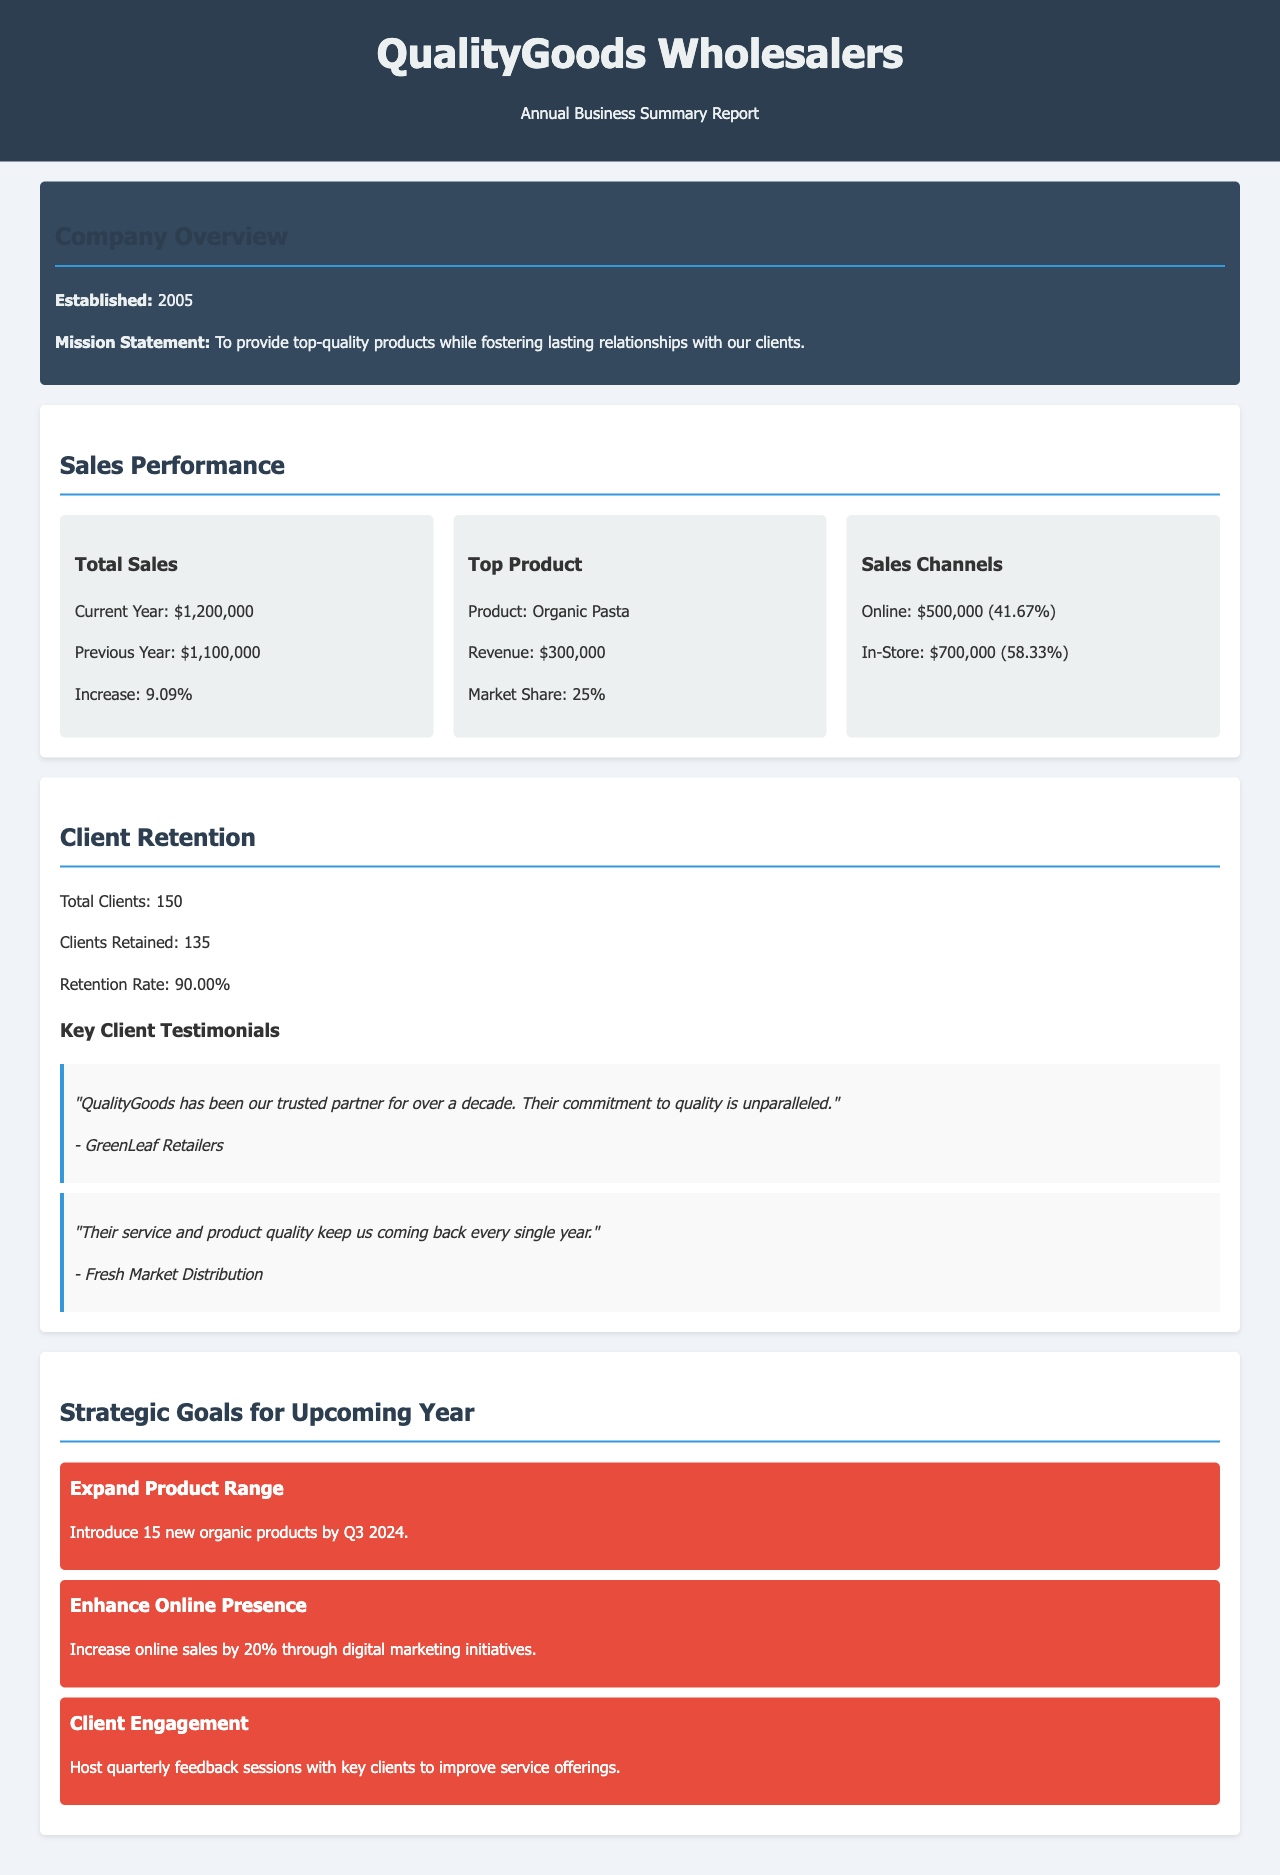What is the total sales for the current year? The total sales for the current year is stated in the sales performance section of the document as $1,200,000.
Answer: $1,200,000 What is the retention rate? The retention rate is calculated based on the number of clients retained against the total clients, which is provided as 90.00% in the client retention section.
Answer: 90.00% Who is the top product? The document specifies the top product in the sales performance section as Organic Pasta.
Answer: Organic Pasta How many new organic products are planned for introduction by Q3 2024? The strategic goals section outlines the plan to introduce 15 new organic products, making this information available for calculation.
Answer: 15 What percentage of sales comes from online channels? The online sales percentage is provided in the sales channels section, stating it as 41.67%.
Answer: 41.67% What is the mission statement of QualityGoods Wholesalers? The mission statement is explicitly mentioned in the company overview section, emphasizing quality and relationships with clients.
Answer: To provide top-quality products while fostering lasting relationships with our clients How much did sales increase compared to the previous year? The sales increase is detailed in the sales performance section as an increase of 9.09%.
Answer: 9.09% What is the total number of clients? The total number of clients is provided in the client retention section, indicating there are 150 clients in total.
Answer: 150 How many feedback sessions are planned with key clients? The client engagement goal specifies that quarterly feedback sessions will be hosted, which can be summarized as four sessions per year.
Answer: Quarterly (4 sessions) 